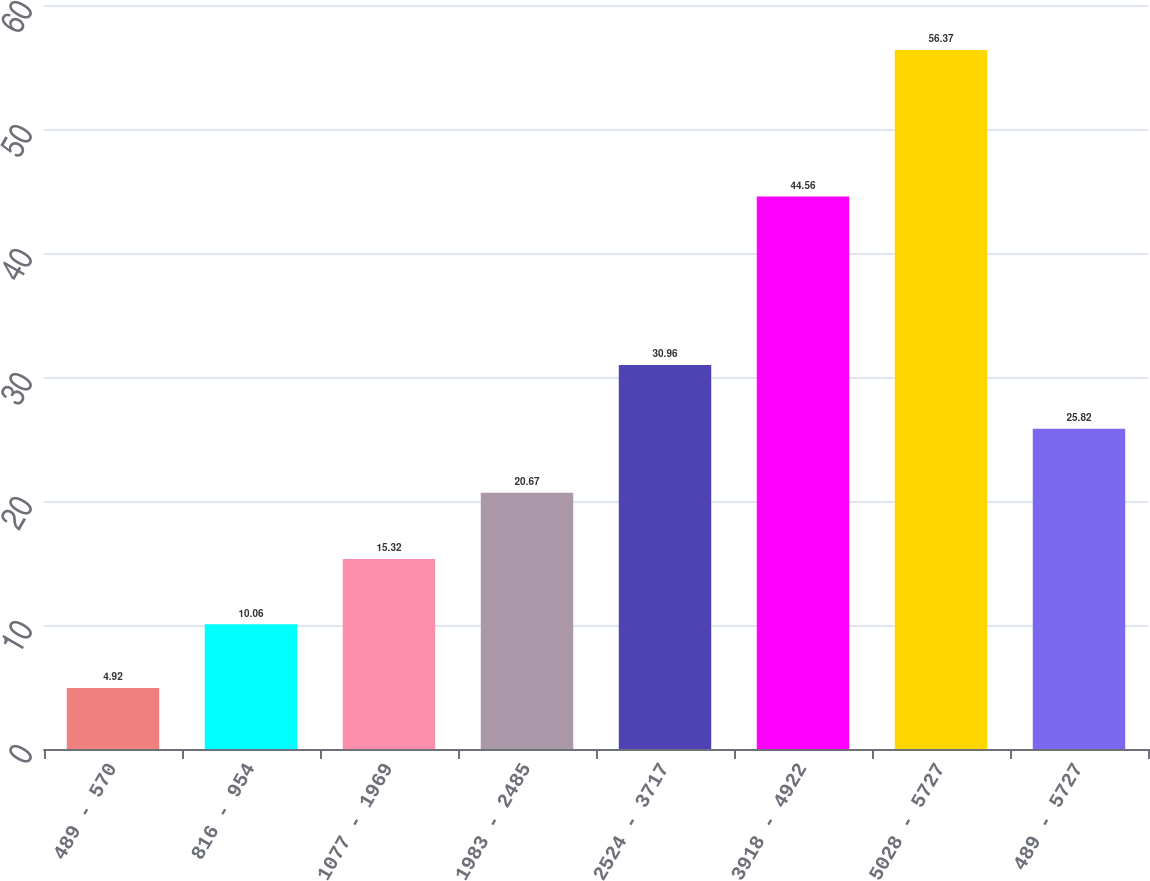Convert chart to OTSL. <chart><loc_0><loc_0><loc_500><loc_500><bar_chart><fcel>489 - 570<fcel>816 - 954<fcel>1077 - 1969<fcel>1983 - 2485<fcel>2524 - 3717<fcel>3918 - 4922<fcel>5028 - 5727<fcel>489 - 5727<nl><fcel>4.92<fcel>10.06<fcel>15.32<fcel>20.67<fcel>30.96<fcel>44.56<fcel>56.37<fcel>25.82<nl></chart> 